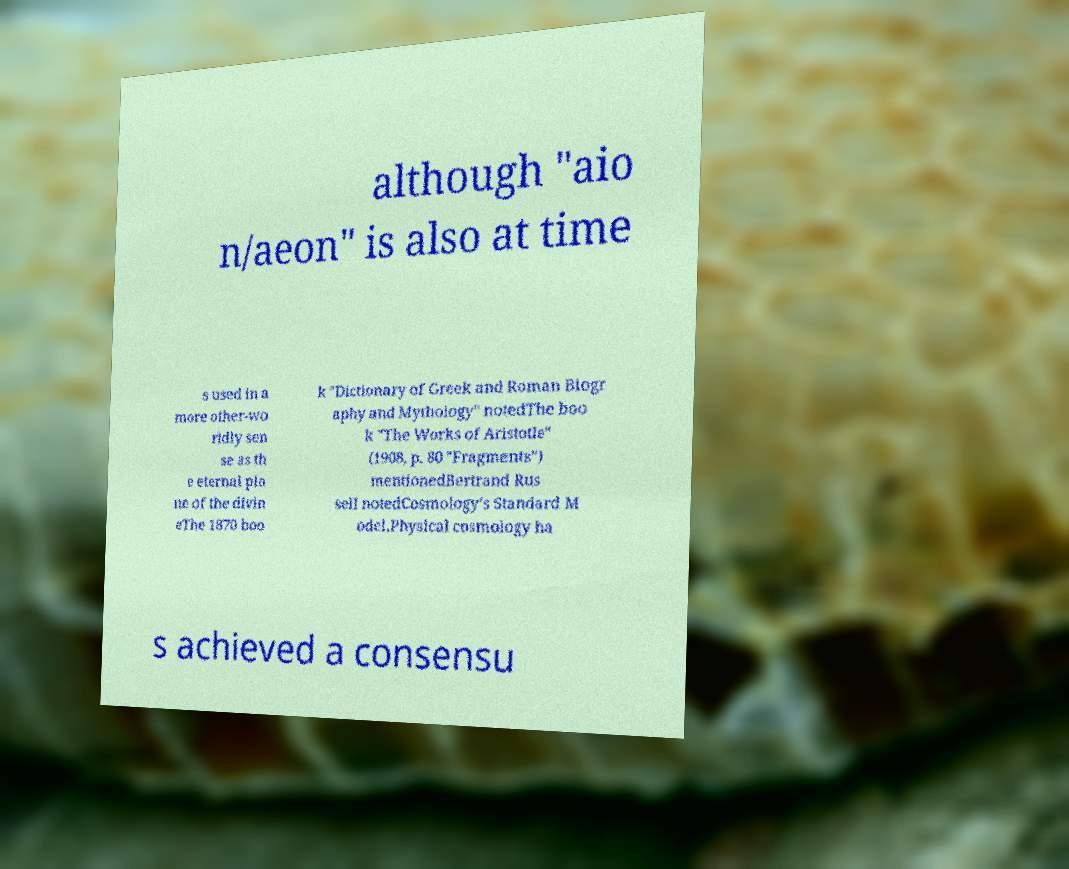Please identify and transcribe the text found in this image. although "aio n/aeon" is also at time s used in a more other-wo rldly sen se as th e eternal pla ne of the divin eThe 1870 boo k "Dictionary of Greek and Roman Biogr aphy and Mythology" notedThe boo k "The Works of Aristotle" (1908, p. 80 "Fragments") mentionedBertrand Rus sell notedCosmology’s Standard M odel.Physical cosmology ha s achieved a consensu 